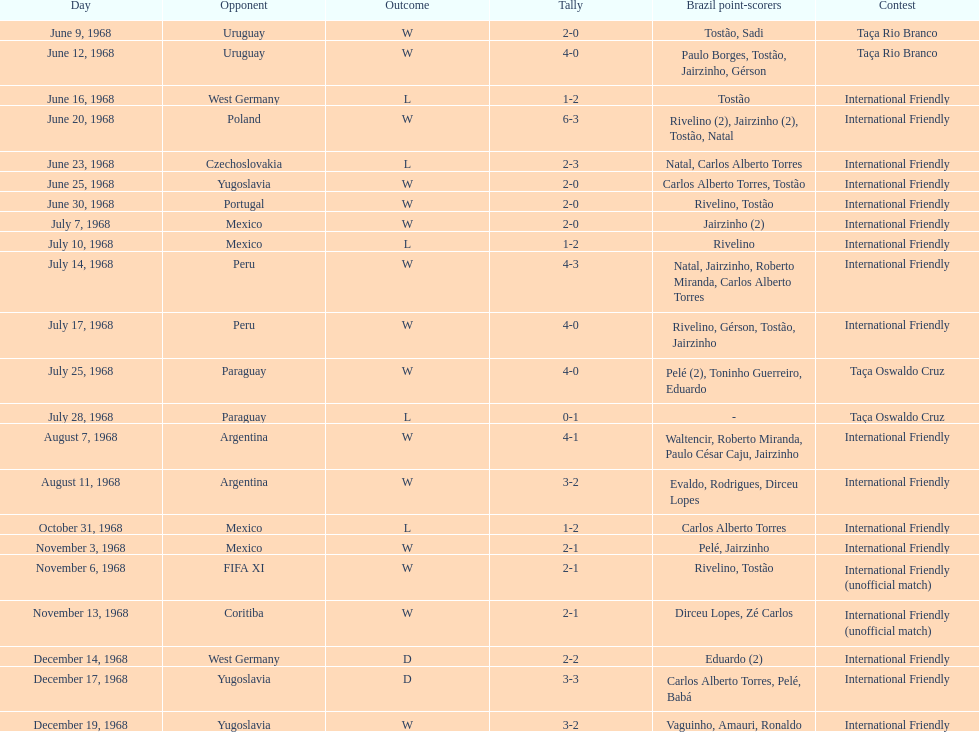Give me the full table as a dictionary. {'header': ['Day', 'Opponent', 'Outcome', 'Tally', 'Brazil point-scorers', 'Contest'], 'rows': [['June 9, 1968', 'Uruguay', 'W', '2-0', 'Tostão, Sadi', 'Taça Rio Branco'], ['June 12, 1968', 'Uruguay', 'W', '4-0', 'Paulo Borges, Tostão, Jairzinho, Gérson', 'Taça Rio Branco'], ['June 16, 1968', 'West Germany', 'L', '1-2', 'Tostão', 'International Friendly'], ['June 20, 1968', 'Poland', 'W', '6-3', 'Rivelino (2), Jairzinho (2), Tostão, Natal', 'International Friendly'], ['June 23, 1968', 'Czechoslovakia', 'L', '2-3', 'Natal, Carlos Alberto Torres', 'International Friendly'], ['June 25, 1968', 'Yugoslavia', 'W', '2-0', 'Carlos Alberto Torres, Tostão', 'International Friendly'], ['June 30, 1968', 'Portugal', 'W', '2-0', 'Rivelino, Tostão', 'International Friendly'], ['July 7, 1968', 'Mexico', 'W', '2-0', 'Jairzinho (2)', 'International Friendly'], ['July 10, 1968', 'Mexico', 'L', '1-2', 'Rivelino', 'International Friendly'], ['July 14, 1968', 'Peru', 'W', '4-3', 'Natal, Jairzinho, Roberto Miranda, Carlos Alberto Torres', 'International Friendly'], ['July 17, 1968', 'Peru', 'W', '4-0', 'Rivelino, Gérson, Tostão, Jairzinho', 'International Friendly'], ['July 25, 1968', 'Paraguay', 'W', '4-0', 'Pelé (2), Toninho Guerreiro, Eduardo', 'Taça Oswaldo Cruz'], ['July 28, 1968', 'Paraguay', 'L', '0-1', '-', 'Taça Oswaldo Cruz'], ['August 7, 1968', 'Argentina', 'W', '4-1', 'Waltencir, Roberto Miranda, Paulo César Caju, Jairzinho', 'International Friendly'], ['August 11, 1968', 'Argentina', 'W', '3-2', 'Evaldo, Rodrigues, Dirceu Lopes', 'International Friendly'], ['October 31, 1968', 'Mexico', 'L', '1-2', 'Carlos Alberto Torres', 'International Friendly'], ['November 3, 1968', 'Mexico', 'W', '2-1', 'Pelé, Jairzinho', 'International Friendly'], ['November 6, 1968', 'FIFA XI', 'W', '2-1', 'Rivelino, Tostão', 'International Friendly (unofficial match)'], ['November 13, 1968', 'Coritiba', 'W', '2-1', 'Dirceu Lopes, Zé Carlos', 'International Friendly (unofficial match)'], ['December 14, 1968', 'West Germany', 'D', '2-2', 'Eduardo (2)', 'International Friendly'], ['December 17, 1968', 'Yugoslavia', 'D', '3-3', 'Carlos Alberto Torres, Pelé, Babá', 'International Friendly'], ['December 19, 1968', 'Yugoslavia', 'W', '3-2', 'Vaguinho, Amauri, Ronaldo', 'International Friendly']]} Number of losses 5. 